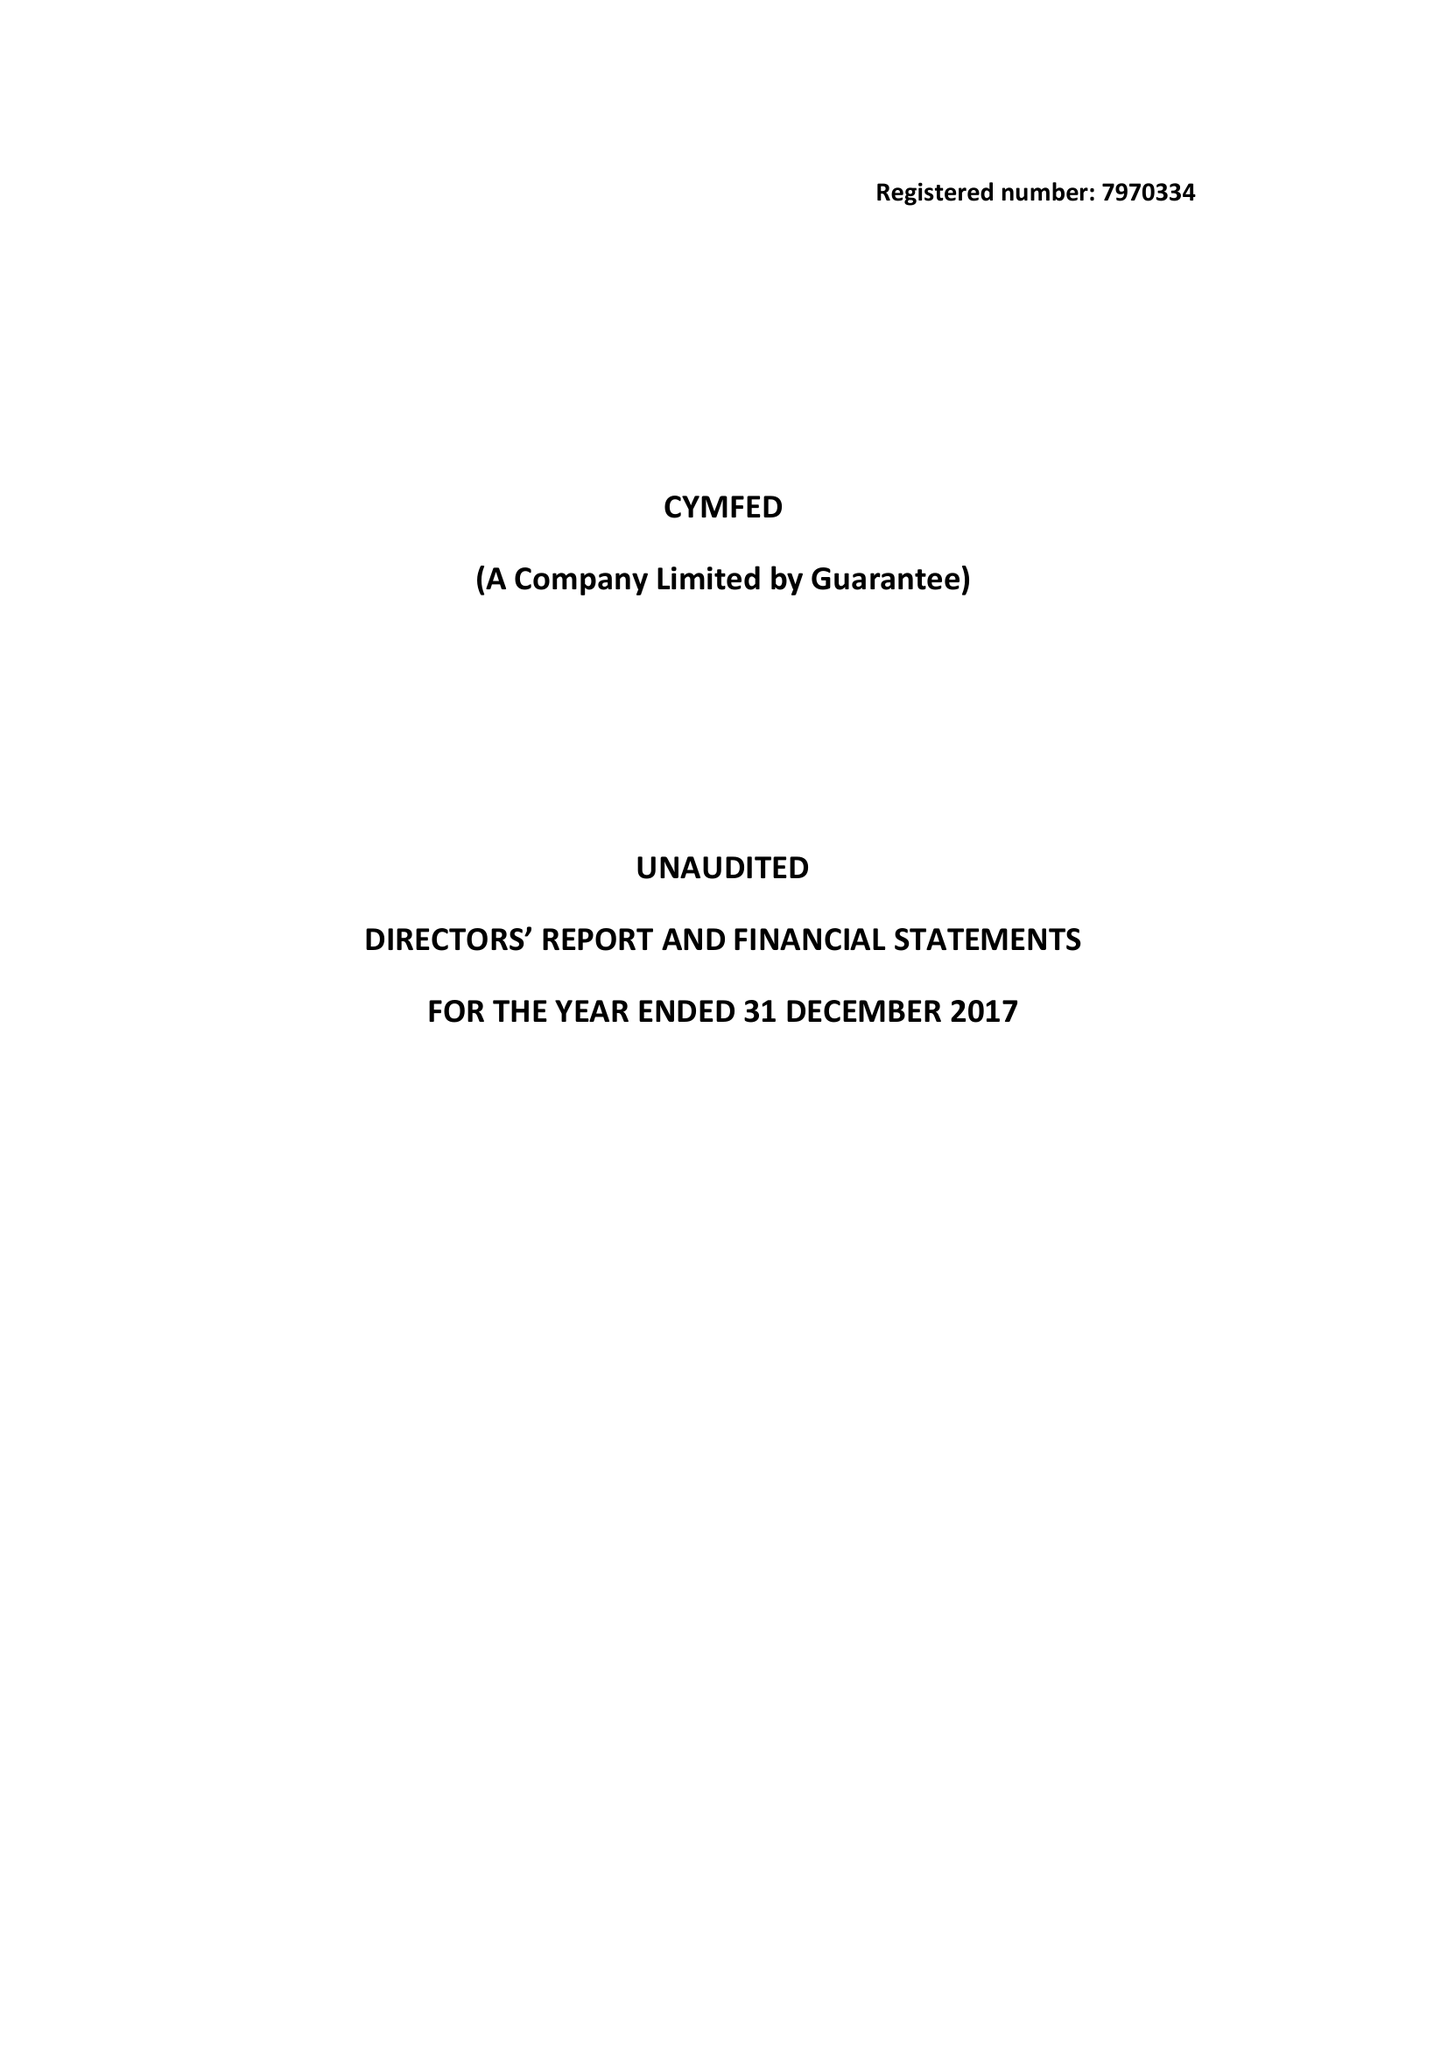What is the value for the address__postcode?
Answer the question using a single word or phrase. SW1V 1BX 